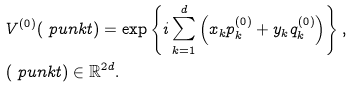Convert formula to latex. <formula><loc_0><loc_0><loc_500><loc_500>& V ^ { ( 0 ) } ( \ p u n k t ) = \exp \left \{ i \sum ^ { d } _ { k = 1 } \left ( x _ { k } p ^ { ( 0 ) } _ { k } + y _ { k } q ^ { ( 0 ) } _ { k } \right ) \right \} , \\ & ( \ p u n k t ) \in \mathbb { R } ^ { 2 d } .</formula> 